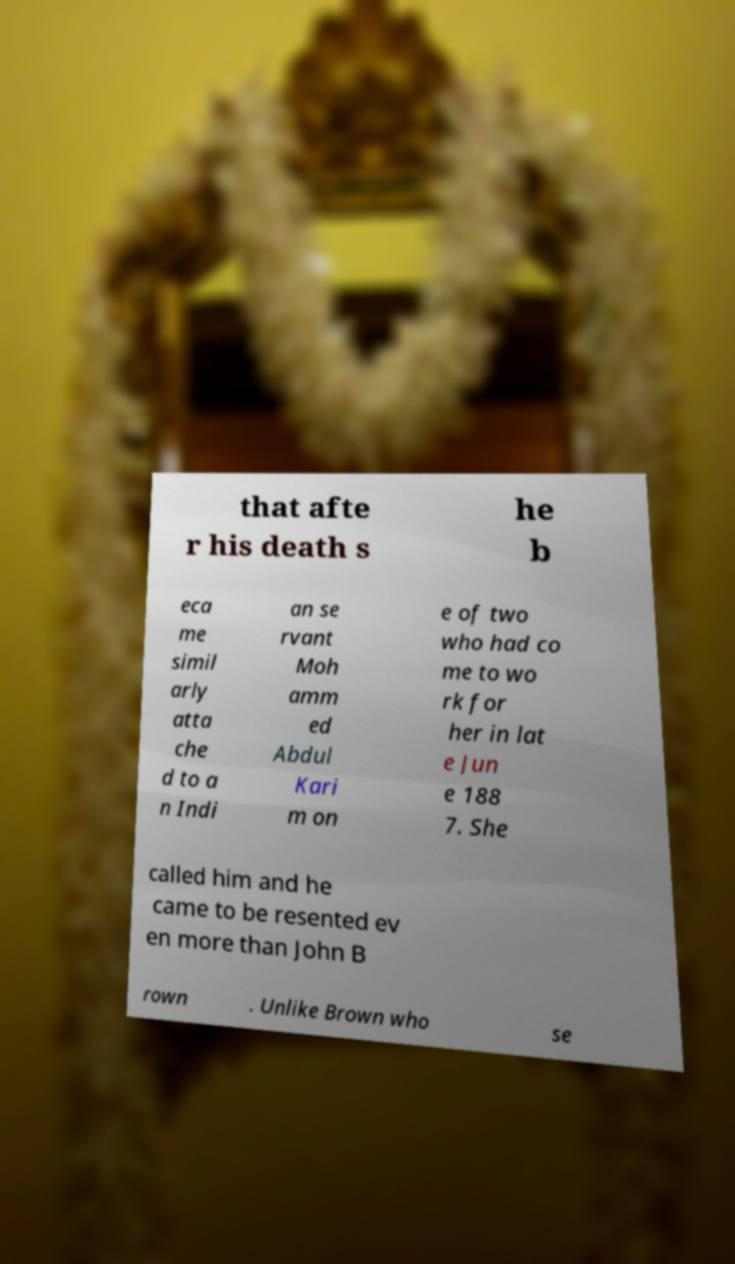Could you assist in decoding the text presented in this image and type it out clearly? that afte r his death s he b eca me simil arly atta che d to a n Indi an se rvant Moh amm ed Abdul Kari m on e of two who had co me to wo rk for her in lat e Jun e 188 7. She called him and he came to be resented ev en more than John B rown . Unlike Brown who se 